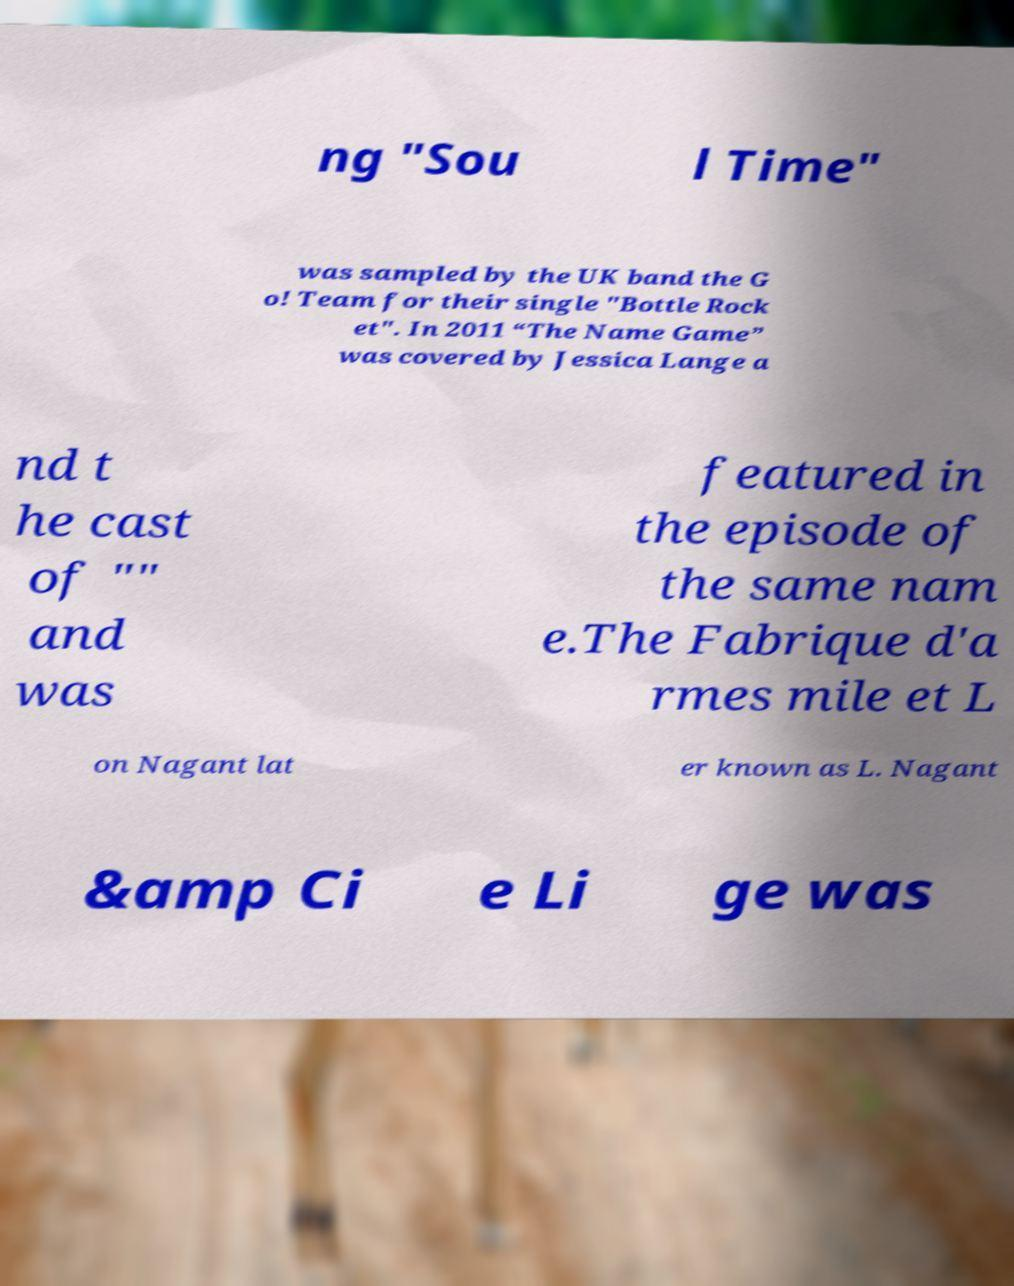Could you assist in decoding the text presented in this image and type it out clearly? ng "Sou l Time" was sampled by the UK band the G o! Team for their single "Bottle Rock et". In 2011 “The Name Game” was covered by Jessica Lange a nd t he cast of "" and was featured in the episode of the same nam e.The Fabrique d'a rmes mile et L on Nagant lat er known as L. Nagant &amp Ci e Li ge was 